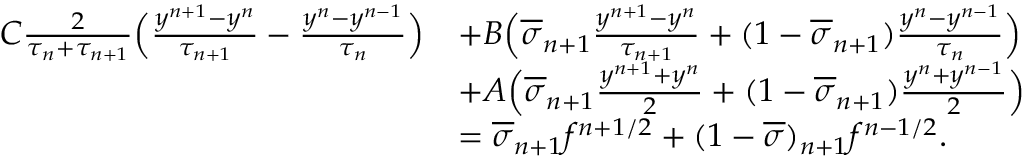Convert formula to latex. <formula><loc_0><loc_0><loc_500><loc_500>\begin{array} { r l } { C \frac { 2 } { \tau _ { n } + \tau _ { n + 1 } } \left ( \frac { y ^ { n + 1 } - y ^ { n } } { \tau _ { n + 1 } } - \frac { y ^ { n } - y ^ { n - 1 } } { \tau _ { n } } \right ) } & { + B \left ( \overline { \sigma } _ { n + 1 } \frac { y ^ { n + 1 } - y ^ { n } } { \tau _ { n + 1 } } + ( 1 - \overline { \sigma } _ { n + 1 } ) \frac { y ^ { n } - y ^ { n - 1 } } { \tau _ { n } } \right ) } \\ & { + A \left ( \overline { \sigma } _ { n + 1 } \frac { y ^ { n + 1 } + y ^ { n } } { 2 } + ( 1 - \overline { \sigma } _ { n + 1 } ) \frac { y ^ { n } + y ^ { n - 1 } } { 2 } \right ) } \\ & { = \overline { \sigma } _ { n + 1 } f ^ { n + 1 / 2 } + ( 1 - \overline { \sigma } ) _ { n + 1 } f ^ { n - 1 / 2 } . } \end{array}</formula> 